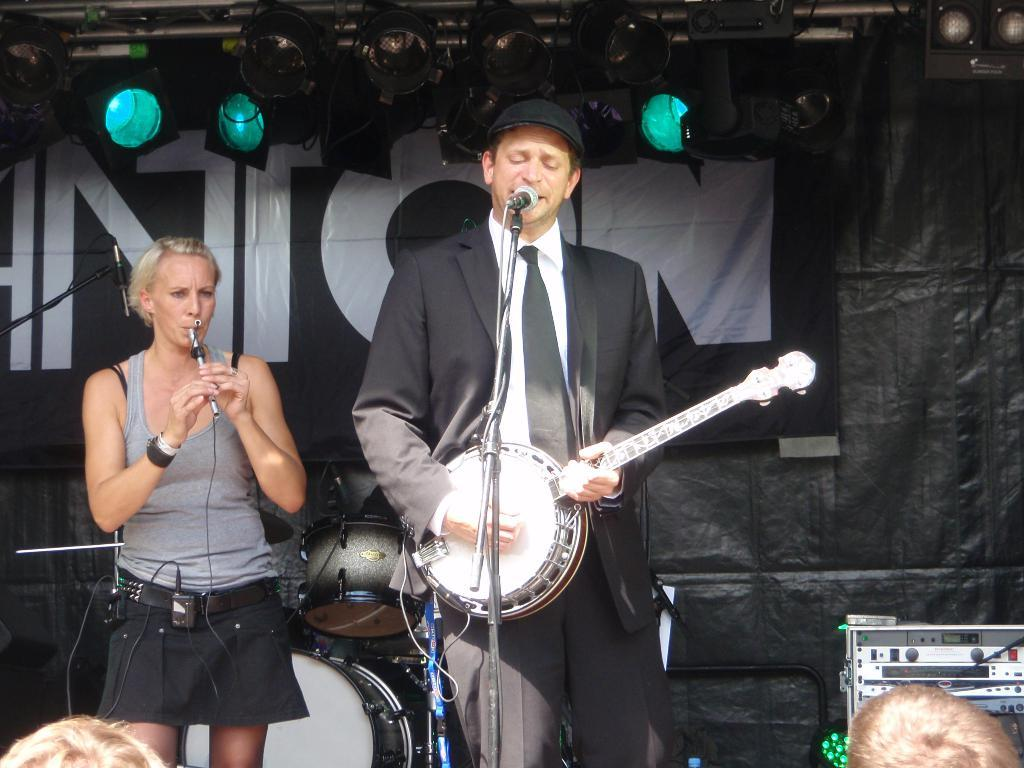How many people are on the stage in the image? There are two persons on the stage in the image. What are the persons on the stage doing? The persons on the stage are playing musical instruments. What can be seen near the persons on the stage? There is a microphone in the image. What else is visible in the image? There are lights visible in the image. What can be seen in the background of the image? There are additional musical instruments in the background. What type of throne is visible in the image? There is no throne present in the image. What religious symbols can be seen in the image? There are no religious symbols present in the image. 